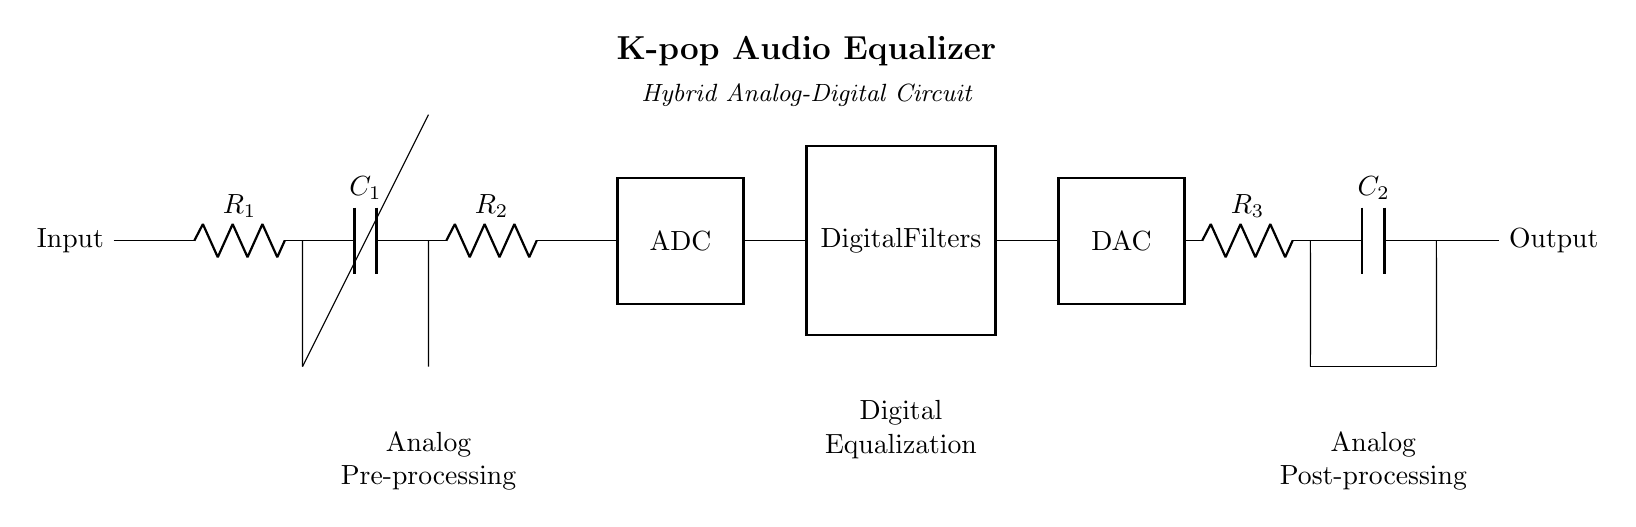What is the main function of this circuit? The main function of this circuit is to enhance audio quality through equalization, making it particularly useful for music playback.
Answer: Audio equalizer What type of components are used in this circuit for analog pre-processing? The components used for analog pre-processing include resistors and capacitors, which filter and shape the audio signal.
Answer: Resistors and capacitors How many operational amplifiers are present in the circuit? There are two operational amplifiers present in the circuit, shown in the analog processing and output stages.
Answer: Two What is the role of the digital filters in this circuit? The digital filters process the digitized audio signal for equalization and enhancement, allowing for more precise control over the audio output.
Answer: Equalization and enhancement Explain the flow of audio signals from input to output in this circuit. The audio signals flow from the input through resistors and capacitors in the analog section, are digitized by the ADC, processed by digital filters for equalization, converted back to analog by the DAC, and further processed by resistors and capacitors before reaching the output stage.
Answer: Input to output flow 